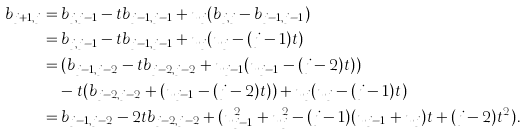Convert formula to latex. <formula><loc_0><loc_0><loc_500><loc_500>b _ { j + 1 , j } & = b _ { j , j - 1 } - t b _ { j - 1 , j - 1 } + u _ { j } ( b _ { j , j } - b _ { j - 1 , j - 1 } ) \\ & = b _ { j , j - 1 } - t b _ { j - 1 , j - 1 } + u _ { j } ( u _ { j } - ( j - 1 ) t ) \\ & = ( b _ { j - 1 , j - 2 } - t b _ { j - 2 , j - 2 } + u _ { j - 1 } ( u _ { j - 1 } - ( j - 2 ) t ) ) \\ & \quad - t ( b _ { j - 2 , j - 2 } + ( u _ { j - 1 } - ( j - 2 ) t ) ) + u _ { j } ( u _ { j } - ( j - 1 ) t ) \\ & = b _ { j - 1 , j - 2 } - 2 t b _ { j - 2 , j - 2 } + ( u _ { j - 1 } ^ { 2 } + u _ { j } ^ { 2 } - ( j - 1 ) ( u _ { j - 1 } + u _ { j } ) t + ( j - 2 ) t ^ { 2 } ) .</formula> 